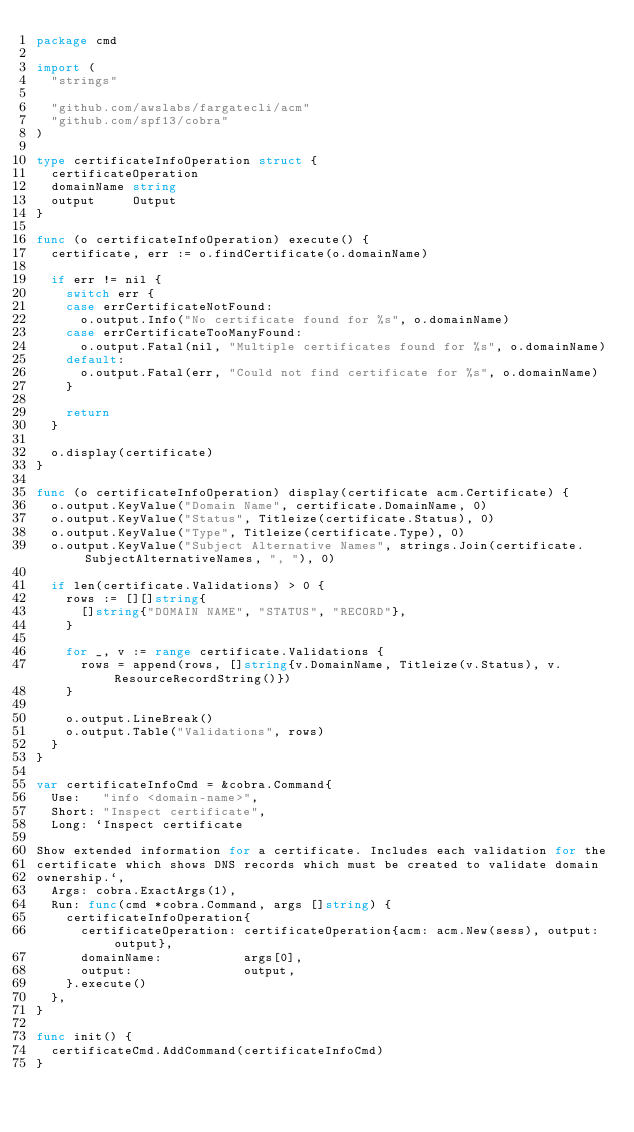<code> <loc_0><loc_0><loc_500><loc_500><_Go_>package cmd

import (
	"strings"

	"github.com/awslabs/fargatecli/acm"
	"github.com/spf13/cobra"
)

type certificateInfoOperation struct {
	certificateOperation
	domainName string
	output     Output
}

func (o certificateInfoOperation) execute() {
	certificate, err := o.findCertificate(o.domainName)

	if err != nil {
		switch err {
		case errCertificateNotFound:
			o.output.Info("No certificate found for %s", o.domainName)
		case errCertificateTooManyFound:
			o.output.Fatal(nil, "Multiple certificates found for %s", o.domainName)
		default:
			o.output.Fatal(err, "Could not find certificate for %s", o.domainName)
		}

		return
	}

	o.display(certificate)
}

func (o certificateInfoOperation) display(certificate acm.Certificate) {
	o.output.KeyValue("Domain Name", certificate.DomainName, 0)
	o.output.KeyValue("Status", Titleize(certificate.Status), 0)
	o.output.KeyValue("Type", Titleize(certificate.Type), 0)
	o.output.KeyValue("Subject Alternative Names", strings.Join(certificate.SubjectAlternativeNames, ", "), 0)

	if len(certificate.Validations) > 0 {
		rows := [][]string{
			[]string{"DOMAIN NAME", "STATUS", "RECORD"},
		}

		for _, v := range certificate.Validations {
			rows = append(rows, []string{v.DomainName, Titleize(v.Status), v.ResourceRecordString()})
		}

		o.output.LineBreak()
		o.output.Table("Validations", rows)
	}
}

var certificateInfoCmd = &cobra.Command{
	Use:   "info <domain-name>",
	Short: "Inspect certificate",
	Long: `Inspect certificate

Show extended information for a certificate. Includes each validation for the
certificate which shows DNS records which must be created to validate domain
ownership.`,
	Args: cobra.ExactArgs(1),
	Run: func(cmd *cobra.Command, args []string) {
		certificateInfoOperation{
			certificateOperation: certificateOperation{acm: acm.New(sess), output: output},
			domainName:           args[0],
			output:               output,
		}.execute()
	},
}

func init() {
	certificateCmd.AddCommand(certificateInfoCmd)
}
</code> 